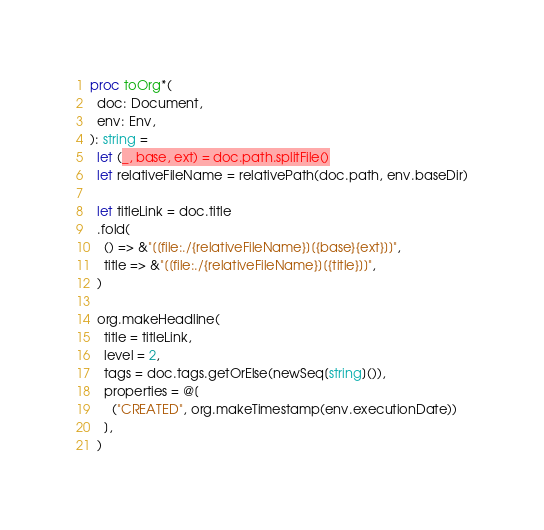<code> <loc_0><loc_0><loc_500><loc_500><_Nim_>proc toOrg*(
  doc: Document,
  env: Env,
): string =
  let (_, base, ext) = doc.path.splitFile()
  let relativeFileName = relativePath(doc.path, env.baseDir)

  let titleLink = doc.title
  .fold(
    () => &"[[file:./{relativeFileName}][{base}{ext}]]",
    title => &"[[file:./{relativeFileName}][{title}]]",
  )

  org.makeHeadline(
    title = titleLink,
    level = 2,
    tags = doc.tags.getOrElse(newSeq[string]()),
    properties = @[
      ("CREATED", org.makeTimestamp(env.executionDate))
    ],
  )
</code> 